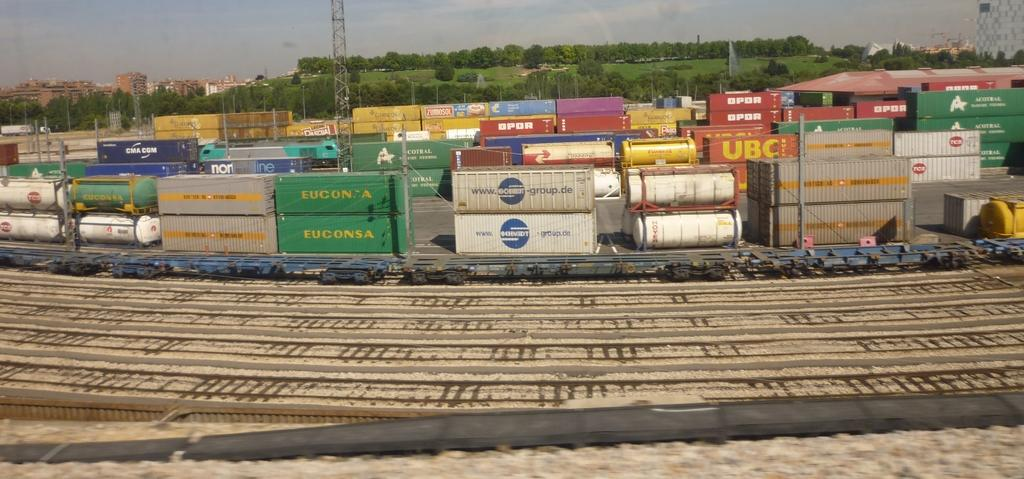<image>
Share a concise interpretation of the image provided. A train car labelled UBC sits with other cars. 